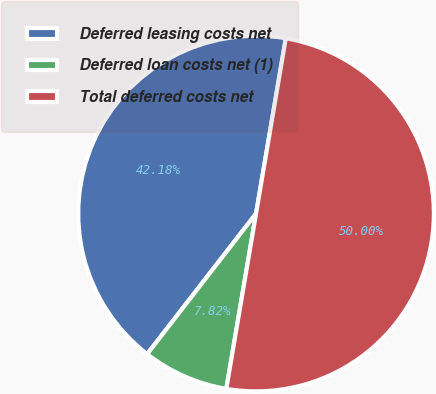Convert chart to OTSL. <chart><loc_0><loc_0><loc_500><loc_500><pie_chart><fcel>Deferred leasing costs net<fcel>Deferred loan costs net (1)<fcel>Total deferred costs net<nl><fcel>42.18%<fcel>7.82%<fcel>50.0%<nl></chart> 